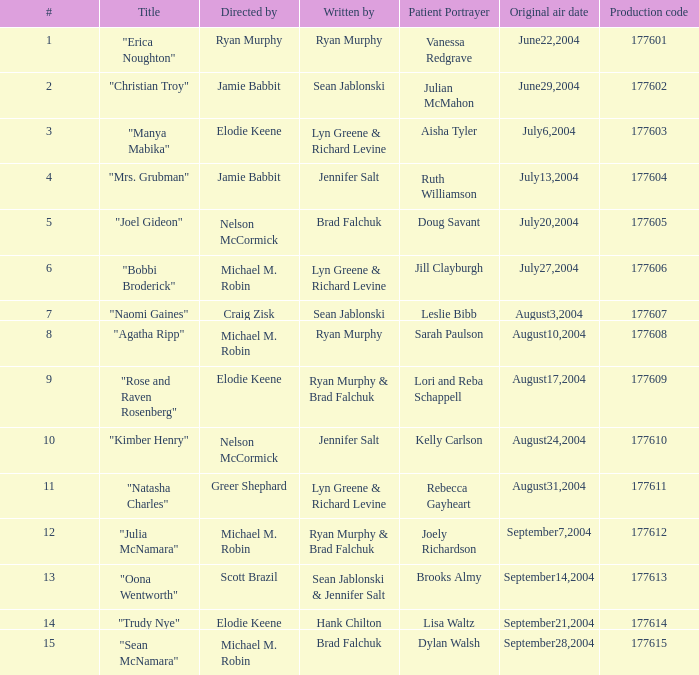Parse the table in full. {'header': ['#', 'Title', 'Directed by', 'Written by', 'Patient Portrayer', 'Original air date', 'Production code'], 'rows': [['1', '"Erica Noughton"', 'Ryan Murphy', 'Ryan Murphy', 'Vanessa Redgrave', 'June22,2004', '177601'], ['2', '"Christian Troy"', 'Jamie Babbit', 'Sean Jablonski', 'Julian McMahon', 'June29,2004', '177602'], ['3', '"Manya Mabika"', 'Elodie Keene', 'Lyn Greene & Richard Levine', 'Aisha Tyler', 'July6,2004', '177603'], ['4', '"Mrs. Grubman"', 'Jamie Babbit', 'Jennifer Salt', 'Ruth Williamson', 'July13,2004', '177604'], ['5', '"Joel Gideon"', 'Nelson McCormick', 'Brad Falchuk', 'Doug Savant', 'July20,2004', '177605'], ['6', '"Bobbi Broderick"', 'Michael M. Robin', 'Lyn Greene & Richard Levine', 'Jill Clayburgh', 'July27,2004', '177606'], ['7', '"Naomi Gaines"', 'Craig Zisk', 'Sean Jablonski', 'Leslie Bibb', 'August3,2004', '177607'], ['8', '"Agatha Ripp"', 'Michael M. Robin', 'Ryan Murphy', 'Sarah Paulson', 'August10,2004', '177608'], ['9', '"Rose and Raven Rosenberg"', 'Elodie Keene', 'Ryan Murphy & Brad Falchuk', 'Lori and Reba Schappell', 'August17,2004', '177609'], ['10', '"Kimber Henry"', 'Nelson McCormick', 'Jennifer Salt', 'Kelly Carlson', 'August24,2004', '177610'], ['11', '"Natasha Charles"', 'Greer Shephard', 'Lyn Greene & Richard Levine', 'Rebecca Gayheart', 'August31,2004', '177611'], ['12', '"Julia McNamara"', 'Michael M. Robin', 'Ryan Murphy & Brad Falchuk', 'Joely Richardson', 'September7,2004', '177612'], ['13', '"Oona Wentworth"', 'Scott Brazil', 'Sean Jablonski & Jennifer Salt', 'Brooks Almy', 'September14,2004', '177613'], ['14', '"Trudy Nye"', 'Elodie Keene', 'Hank Chilton', 'Lisa Waltz', 'September21,2004', '177614'], ['15', '"Sean McNamara"', 'Michael M. Robin', 'Brad Falchuk', 'Dylan Walsh', 'September28,2004', '177615']]} What is the highest numbered episode with patient portrayer doug savant? 5.0. 